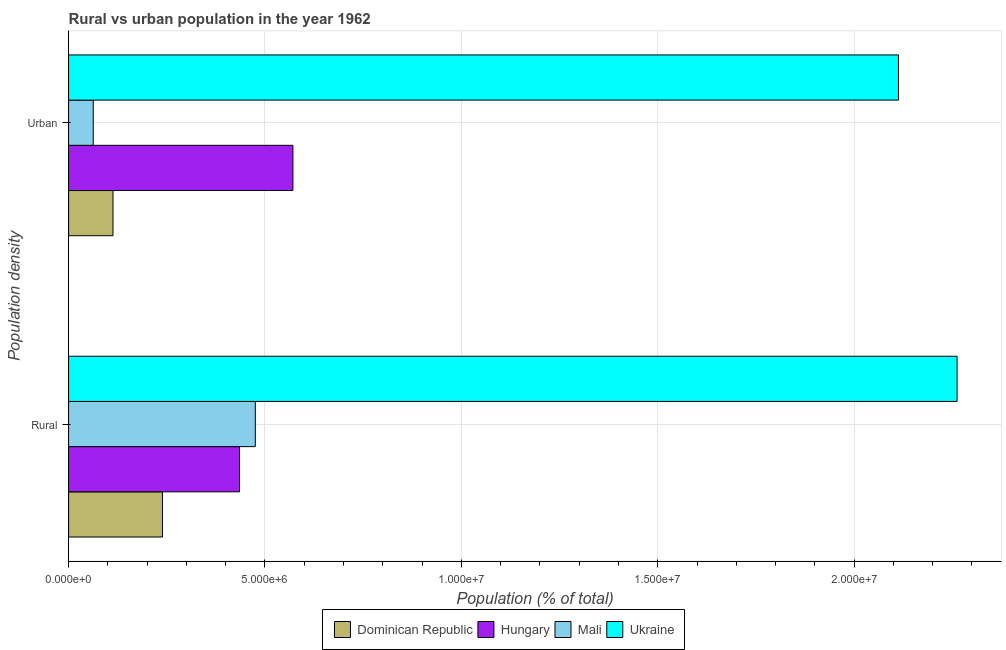How many bars are there on the 2nd tick from the top?
Keep it short and to the point. 4. How many bars are there on the 1st tick from the bottom?
Keep it short and to the point. 4. What is the label of the 1st group of bars from the top?
Provide a short and direct response. Urban. What is the urban population density in Mali?
Offer a terse response. 6.28e+05. Across all countries, what is the maximum urban population density?
Provide a succinct answer. 2.11e+07. Across all countries, what is the minimum urban population density?
Offer a very short reply. 6.28e+05. In which country was the rural population density maximum?
Offer a terse response. Ukraine. In which country was the urban population density minimum?
Your answer should be compact. Mali. What is the total urban population density in the graph?
Ensure brevity in your answer.  2.86e+07. What is the difference between the urban population density in Mali and that in Ukraine?
Provide a short and direct response. -2.05e+07. What is the difference between the rural population density in Mali and the urban population density in Dominican Republic?
Provide a succinct answer. 3.62e+06. What is the average urban population density per country?
Make the answer very short. 7.15e+06. What is the difference between the urban population density and rural population density in Mali?
Your answer should be compact. -4.13e+06. What is the ratio of the urban population density in Mali to that in Dominican Republic?
Keep it short and to the point. 0.56. In how many countries, is the urban population density greater than the average urban population density taken over all countries?
Make the answer very short. 1. What does the 2nd bar from the top in Urban represents?
Ensure brevity in your answer.  Mali. What does the 3rd bar from the bottom in Urban represents?
Keep it short and to the point. Mali. How many bars are there?
Your answer should be very brief. 8. Are all the bars in the graph horizontal?
Make the answer very short. Yes. How many countries are there in the graph?
Your answer should be compact. 4. What is the difference between two consecutive major ticks on the X-axis?
Make the answer very short. 5.00e+06. How many legend labels are there?
Your answer should be very brief. 4. How are the legend labels stacked?
Offer a very short reply. Horizontal. What is the title of the graph?
Your response must be concise. Rural vs urban population in the year 1962. Does "Japan" appear as one of the legend labels in the graph?
Your response must be concise. No. What is the label or title of the X-axis?
Ensure brevity in your answer.  Population (% of total). What is the label or title of the Y-axis?
Offer a very short reply. Population density. What is the Population (% of total) of Dominican Republic in Rural?
Keep it short and to the point. 2.39e+06. What is the Population (% of total) in Hungary in Rural?
Provide a short and direct response. 4.35e+06. What is the Population (% of total) in Mali in Rural?
Give a very brief answer. 4.75e+06. What is the Population (% of total) in Ukraine in Rural?
Offer a terse response. 2.26e+07. What is the Population (% of total) in Dominican Republic in Urban?
Your response must be concise. 1.13e+06. What is the Population (% of total) in Hungary in Urban?
Offer a very short reply. 5.71e+06. What is the Population (% of total) of Mali in Urban?
Ensure brevity in your answer.  6.28e+05. What is the Population (% of total) of Ukraine in Urban?
Your response must be concise. 2.11e+07. Across all Population density, what is the maximum Population (% of total) of Dominican Republic?
Provide a short and direct response. 2.39e+06. Across all Population density, what is the maximum Population (% of total) of Hungary?
Ensure brevity in your answer.  5.71e+06. Across all Population density, what is the maximum Population (% of total) of Mali?
Your answer should be very brief. 4.75e+06. Across all Population density, what is the maximum Population (% of total) in Ukraine?
Your answer should be very brief. 2.26e+07. Across all Population density, what is the minimum Population (% of total) of Dominican Republic?
Make the answer very short. 1.13e+06. Across all Population density, what is the minimum Population (% of total) in Hungary?
Offer a very short reply. 4.35e+06. Across all Population density, what is the minimum Population (% of total) in Mali?
Your answer should be compact. 6.28e+05. Across all Population density, what is the minimum Population (% of total) in Ukraine?
Give a very brief answer. 2.11e+07. What is the total Population (% of total) in Dominican Republic in the graph?
Give a very brief answer. 3.52e+06. What is the total Population (% of total) of Hungary in the graph?
Provide a succinct answer. 1.01e+07. What is the total Population (% of total) in Mali in the graph?
Your response must be concise. 5.38e+06. What is the total Population (% of total) in Ukraine in the graph?
Make the answer very short. 4.37e+07. What is the difference between the Population (% of total) of Dominican Republic in Rural and that in Urban?
Offer a very short reply. 1.26e+06. What is the difference between the Population (% of total) of Hungary in Rural and that in Urban?
Your answer should be very brief. -1.36e+06. What is the difference between the Population (% of total) of Mali in Rural and that in Urban?
Your answer should be very brief. 4.13e+06. What is the difference between the Population (% of total) in Ukraine in Rural and that in Urban?
Your response must be concise. 1.49e+06. What is the difference between the Population (% of total) of Dominican Republic in Rural and the Population (% of total) of Hungary in Urban?
Offer a very short reply. -3.32e+06. What is the difference between the Population (% of total) of Dominican Republic in Rural and the Population (% of total) of Mali in Urban?
Your answer should be very brief. 1.76e+06. What is the difference between the Population (% of total) in Dominican Republic in Rural and the Population (% of total) in Ukraine in Urban?
Make the answer very short. -1.87e+07. What is the difference between the Population (% of total) in Hungary in Rural and the Population (% of total) in Mali in Urban?
Make the answer very short. 3.72e+06. What is the difference between the Population (% of total) in Hungary in Rural and the Population (% of total) in Ukraine in Urban?
Make the answer very short. -1.68e+07. What is the difference between the Population (% of total) of Mali in Rural and the Population (% of total) of Ukraine in Urban?
Give a very brief answer. -1.64e+07. What is the average Population (% of total) in Dominican Republic per Population density?
Make the answer very short. 1.76e+06. What is the average Population (% of total) in Hungary per Population density?
Offer a very short reply. 5.03e+06. What is the average Population (% of total) of Mali per Population density?
Make the answer very short. 2.69e+06. What is the average Population (% of total) in Ukraine per Population density?
Your answer should be very brief. 2.19e+07. What is the difference between the Population (% of total) of Dominican Republic and Population (% of total) of Hungary in Rural?
Give a very brief answer. -1.96e+06. What is the difference between the Population (% of total) of Dominican Republic and Population (% of total) of Mali in Rural?
Provide a succinct answer. -2.36e+06. What is the difference between the Population (% of total) of Dominican Republic and Population (% of total) of Ukraine in Rural?
Provide a succinct answer. -2.02e+07. What is the difference between the Population (% of total) in Hungary and Population (% of total) in Mali in Rural?
Your response must be concise. -4.03e+05. What is the difference between the Population (% of total) in Hungary and Population (% of total) in Ukraine in Rural?
Provide a succinct answer. -1.83e+07. What is the difference between the Population (% of total) in Mali and Population (% of total) in Ukraine in Rural?
Ensure brevity in your answer.  -1.79e+07. What is the difference between the Population (% of total) in Dominican Republic and Population (% of total) in Hungary in Urban?
Your answer should be very brief. -4.58e+06. What is the difference between the Population (% of total) in Dominican Republic and Population (% of total) in Mali in Urban?
Offer a very short reply. 5.03e+05. What is the difference between the Population (% of total) in Dominican Republic and Population (% of total) in Ukraine in Urban?
Keep it short and to the point. -2.00e+07. What is the difference between the Population (% of total) in Hungary and Population (% of total) in Mali in Urban?
Offer a very short reply. 5.08e+06. What is the difference between the Population (% of total) in Hungary and Population (% of total) in Ukraine in Urban?
Your response must be concise. -1.54e+07. What is the difference between the Population (% of total) of Mali and Population (% of total) of Ukraine in Urban?
Provide a short and direct response. -2.05e+07. What is the ratio of the Population (% of total) of Dominican Republic in Rural to that in Urban?
Provide a short and direct response. 2.12. What is the ratio of the Population (% of total) in Hungary in Rural to that in Urban?
Your response must be concise. 0.76. What is the ratio of the Population (% of total) of Mali in Rural to that in Urban?
Keep it short and to the point. 7.57. What is the ratio of the Population (% of total) of Ukraine in Rural to that in Urban?
Provide a short and direct response. 1.07. What is the difference between the highest and the second highest Population (% of total) of Dominican Republic?
Provide a short and direct response. 1.26e+06. What is the difference between the highest and the second highest Population (% of total) in Hungary?
Provide a short and direct response. 1.36e+06. What is the difference between the highest and the second highest Population (% of total) of Mali?
Your answer should be compact. 4.13e+06. What is the difference between the highest and the second highest Population (% of total) of Ukraine?
Provide a short and direct response. 1.49e+06. What is the difference between the highest and the lowest Population (% of total) of Dominican Republic?
Your answer should be very brief. 1.26e+06. What is the difference between the highest and the lowest Population (% of total) of Hungary?
Your answer should be compact. 1.36e+06. What is the difference between the highest and the lowest Population (% of total) in Mali?
Provide a succinct answer. 4.13e+06. What is the difference between the highest and the lowest Population (% of total) in Ukraine?
Your answer should be very brief. 1.49e+06. 